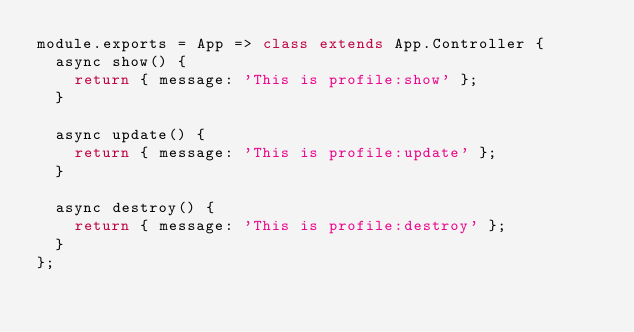Convert code to text. <code><loc_0><loc_0><loc_500><loc_500><_JavaScript_>module.exports = App => class extends App.Controller {
  async show() {
    return { message: 'This is profile:show' };
  }

  async update() {
    return { message: 'This is profile:update' };
  }

  async destroy() {
    return { message: 'This is profile:destroy' };
  }
};
</code> 